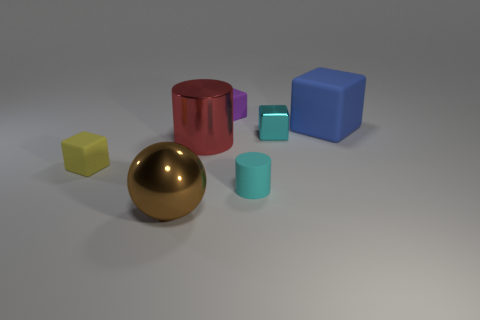What is the largest object in the image? The largest object in the image appears to be the blue cube. 